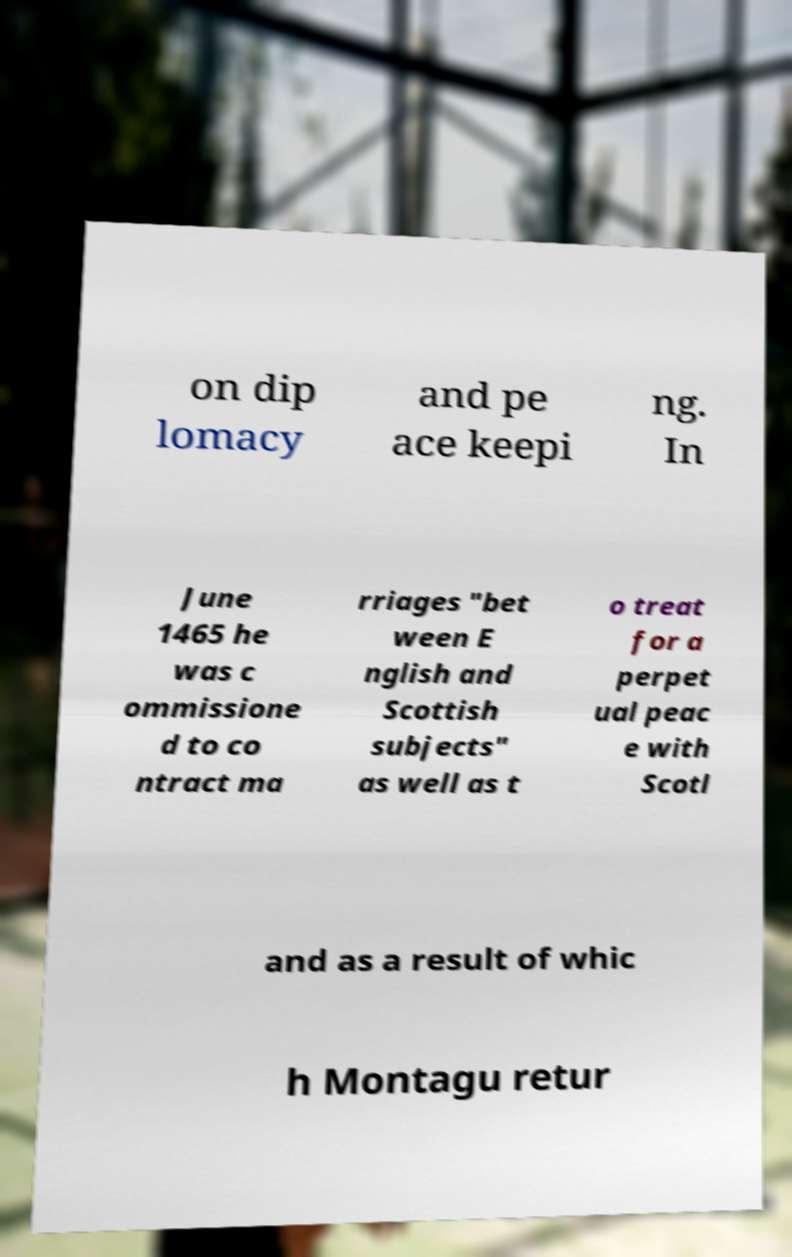Please identify and transcribe the text found in this image. on dip lomacy and pe ace keepi ng. In June 1465 he was c ommissione d to co ntract ma rriages "bet ween E nglish and Scottish subjects" as well as t o treat for a perpet ual peac e with Scotl and as a result of whic h Montagu retur 